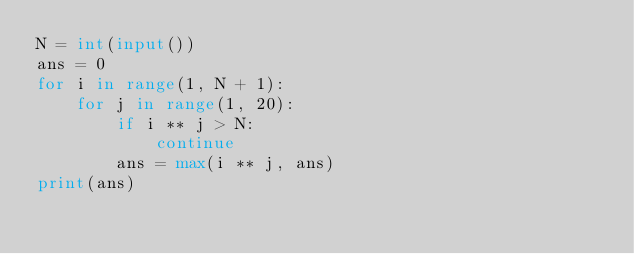Convert code to text. <code><loc_0><loc_0><loc_500><loc_500><_Python_>N = int(input())
ans = 0
for i in range(1, N + 1):
    for j in range(1, 20):
        if i ** j > N:
            continue
        ans = max(i ** j, ans)
print(ans)

</code> 